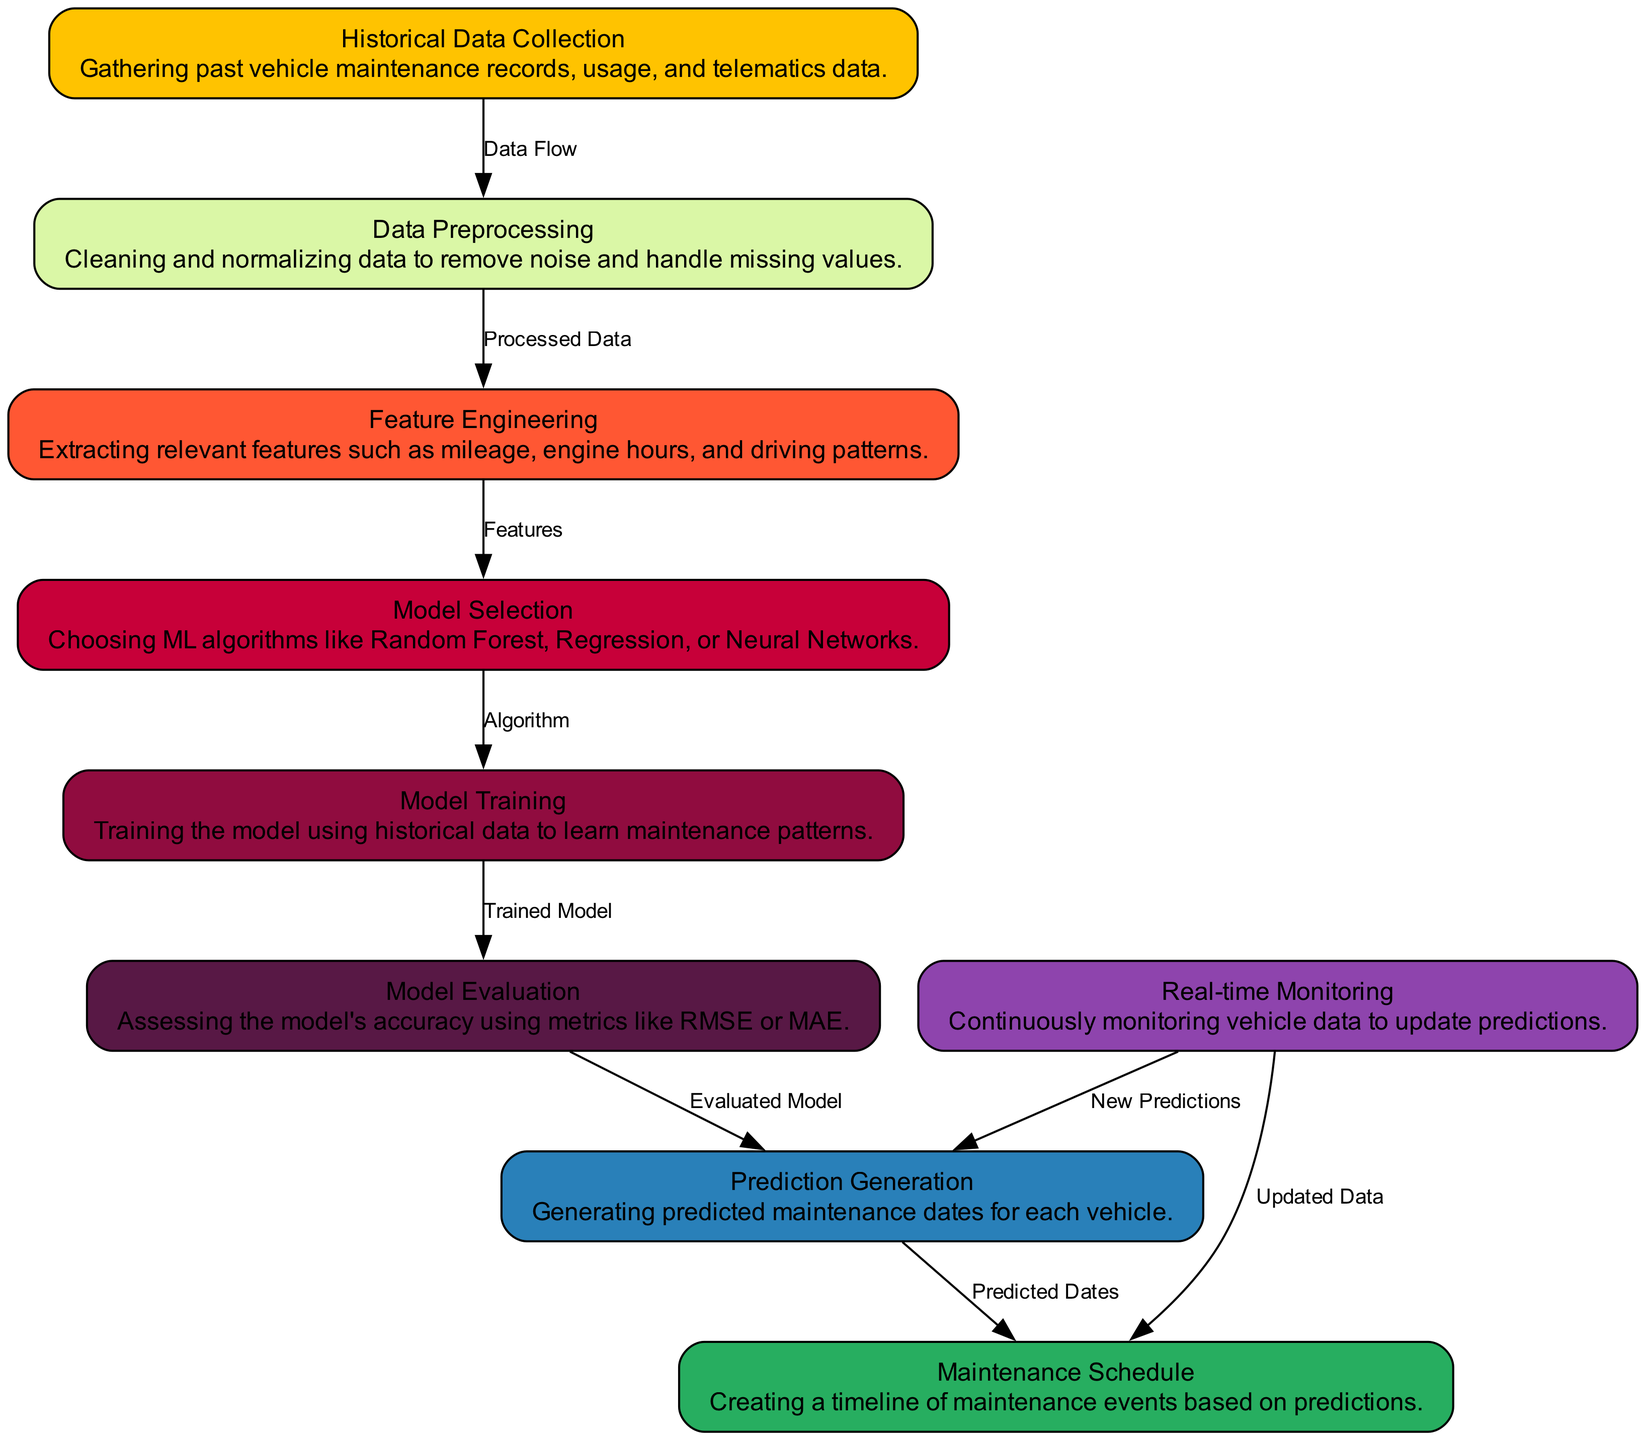What is the first step in the predictive maintenance process? The first step is "Historical Data Collection," where past vehicle maintenance records and usage data are gathered.
Answer: Historical Data Collection How many nodes are present in the diagram? The diagram has 9 nodes, each representing a specific step in the predictive maintenance process.
Answer: 9 What feature is extracted in the feature engineering phase? During feature engineering, relevant features such as mileage, engine hours, and driving patterns are extracted.
Answer: Mileage, engine hours, and driving patterns Which node receives the output from the model training? The output from the model training goes to the "Model Evaluation" node, where the trained model is assessed for accuracy.
Answer: Model Evaluation What directs the flow from prediction generation to maintenance schedule? The directed flow from "Prediction Generation" to "Maintenance Schedule" is labeled as "Predicted Dates."
Answer: Predicted Dates Which node is responsible for updating predictions in real-time? The node responsible for updating predictions in real-time is "Real-time Monitoring."
Answer: Real-time Monitoring What type of data is collected in the historical data collection stage? The historical data collection stage involves gathering past vehicle maintenance records, usage, and telematics data.
Answer: Past vehicle maintenance records, usage, and telematics data How does model selection influence the predictive maintenance process? "Model Selection" influences the predictive maintenance process by choosing suitable ML algorithms that will be used for training the model.
Answer: Choosing ML algorithms How are new predictions generated after real-time monitoring? New predictions are generated from real-time monitoring by continuously updating vehicle data and informing the "Prediction Generation" node.
Answer: Continuously updating vehicle data 